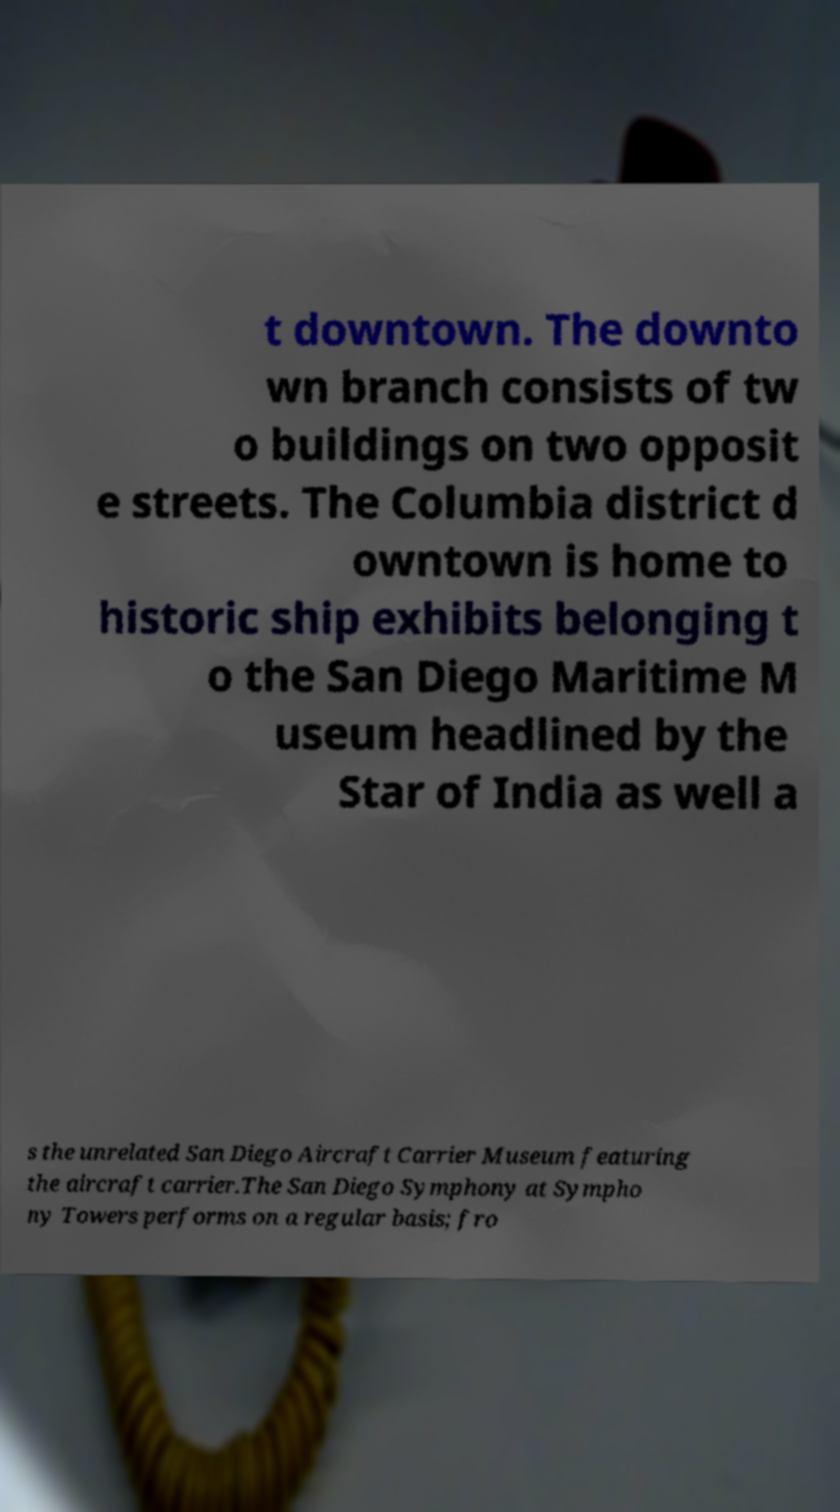I need the written content from this picture converted into text. Can you do that? t downtown. The downto wn branch consists of tw o buildings on two opposit e streets. The Columbia district d owntown is home to historic ship exhibits belonging t o the San Diego Maritime M useum headlined by the Star of India as well a s the unrelated San Diego Aircraft Carrier Museum featuring the aircraft carrier.The San Diego Symphony at Sympho ny Towers performs on a regular basis; fro 